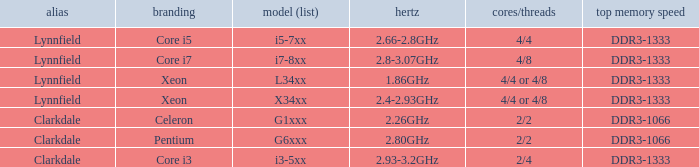What brand is model G6xxx? Pentium. 